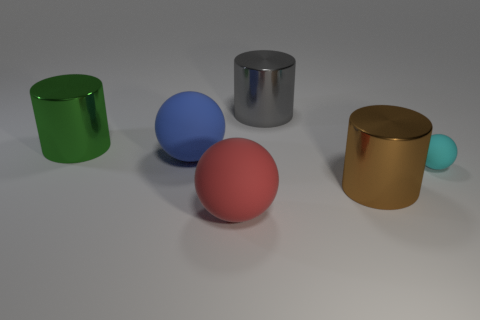There is a gray shiny object that is the same shape as the big green shiny thing; what size is it?
Provide a succinct answer. Large. The object that is in front of the metallic thing that is in front of the large blue matte sphere that is left of the cyan rubber ball is made of what material?
Your answer should be very brief. Rubber. Is there a big gray object?
Make the answer very short. Yes. The small matte ball has what color?
Provide a succinct answer. Cyan. The other small rubber thing that is the same shape as the red thing is what color?
Your answer should be compact. Cyan. Do the cyan object and the big green object have the same shape?
Ensure brevity in your answer.  No. How many cylinders are either blue objects or big metallic things?
Your answer should be compact. 3. The other tiny thing that is made of the same material as the red thing is what color?
Make the answer very short. Cyan. There is a sphere that is right of the gray object; is its size the same as the large gray metallic thing?
Give a very brief answer. No. Does the large brown cylinder have the same material as the large ball that is behind the big red object?
Your answer should be very brief. No. 